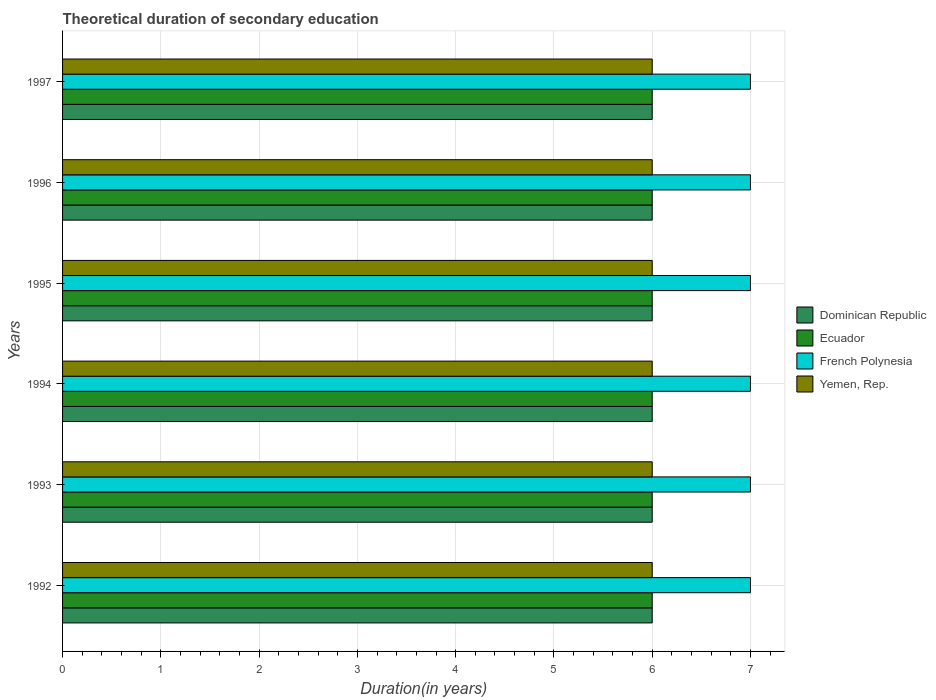How many bars are there on the 2nd tick from the bottom?
Ensure brevity in your answer.  4. In how many cases, is the number of bars for a given year not equal to the number of legend labels?
Your answer should be very brief. 0. Across all years, what is the maximum total theoretical duration of secondary education in Yemen, Rep.?
Offer a terse response. 6. Across all years, what is the minimum total theoretical duration of secondary education in French Polynesia?
Your answer should be compact. 7. In which year was the total theoretical duration of secondary education in French Polynesia maximum?
Ensure brevity in your answer.  1992. In which year was the total theoretical duration of secondary education in Ecuador minimum?
Provide a short and direct response. 1992. What is the total total theoretical duration of secondary education in Yemen, Rep. in the graph?
Provide a short and direct response. 36. What is the difference between the total theoretical duration of secondary education in Ecuador in 1995 and that in 1997?
Your response must be concise. 0. What is the average total theoretical duration of secondary education in French Polynesia per year?
Offer a very short reply. 7. In how many years, is the total theoretical duration of secondary education in Yemen, Rep. greater than 5.6 years?
Your response must be concise. 6. In how many years, is the total theoretical duration of secondary education in Yemen, Rep. greater than the average total theoretical duration of secondary education in Yemen, Rep. taken over all years?
Offer a very short reply. 0. What does the 3rd bar from the top in 1996 represents?
Provide a succinct answer. Ecuador. What does the 3rd bar from the bottom in 1996 represents?
Keep it short and to the point. French Polynesia. How many years are there in the graph?
Your response must be concise. 6. What is the difference between two consecutive major ticks on the X-axis?
Your answer should be compact. 1. Are the values on the major ticks of X-axis written in scientific E-notation?
Make the answer very short. No. Where does the legend appear in the graph?
Offer a very short reply. Center right. How many legend labels are there?
Provide a short and direct response. 4. What is the title of the graph?
Give a very brief answer. Theoretical duration of secondary education. What is the label or title of the X-axis?
Your answer should be compact. Duration(in years). What is the label or title of the Y-axis?
Make the answer very short. Years. What is the Duration(in years) in Dominican Republic in 1992?
Provide a short and direct response. 6. What is the Duration(in years) in Yemen, Rep. in 1992?
Keep it short and to the point. 6. What is the Duration(in years) in Yemen, Rep. in 1993?
Your answer should be compact. 6. What is the Duration(in years) in Ecuador in 1994?
Your answer should be very brief. 6. What is the Duration(in years) in French Polynesia in 1994?
Your answer should be compact. 7. What is the Duration(in years) of Yemen, Rep. in 1994?
Provide a succinct answer. 6. What is the Duration(in years) of Ecuador in 1995?
Provide a succinct answer. 6. What is the Duration(in years) of French Polynesia in 1995?
Your answer should be compact. 7. What is the Duration(in years) in French Polynesia in 1996?
Keep it short and to the point. 7. Across all years, what is the maximum Duration(in years) in Dominican Republic?
Keep it short and to the point. 6. Across all years, what is the maximum Duration(in years) of French Polynesia?
Make the answer very short. 7. Across all years, what is the maximum Duration(in years) in Yemen, Rep.?
Make the answer very short. 6. Across all years, what is the minimum Duration(in years) of Dominican Republic?
Your answer should be compact. 6. Across all years, what is the minimum Duration(in years) in French Polynesia?
Give a very brief answer. 7. What is the total Duration(in years) in French Polynesia in the graph?
Offer a very short reply. 42. What is the total Duration(in years) of Yemen, Rep. in the graph?
Your answer should be very brief. 36. What is the difference between the Duration(in years) in Dominican Republic in 1992 and that in 1993?
Keep it short and to the point. 0. What is the difference between the Duration(in years) in Ecuador in 1992 and that in 1993?
Your answer should be compact. 0. What is the difference between the Duration(in years) in French Polynesia in 1992 and that in 1993?
Offer a terse response. 0. What is the difference between the Duration(in years) of Yemen, Rep. in 1992 and that in 1993?
Provide a short and direct response. 0. What is the difference between the Duration(in years) of Dominican Republic in 1992 and that in 1994?
Provide a short and direct response. 0. What is the difference between the Duration(in years) of French Polynesia in 1992 and that in 1994?
Your answer should be very brief. 0. What is the difference between the Duration(in years) in Yemen, Rep. in 1992 and that in 1994?
Provide a short and direct response. 0. What is the difference between the Duration(in years) in Dominican Republic in 1992 and that in 1995?
Provide a succinct answer. 0. What is the difference between the Duration(in years) of Ecuador in 1992 and that in 1995?
Provide a succinct answer. 0. What is the difference between the Duration(in years) in French Polynesia in 1992 and that in 1995?
Your response must be concise. 0. What is the difference between the Duration(in years) of Yemen, Rep. in 1992 and that in 1995?
Your answer should be very brief. 0. What is the difference between the Duration(in years) in Dominican Republic in 1992 and that in 1996?
Your response must be concise. 0. What is the difference between the Duration(in years) in Ecuador in 1992 and that in 1996?
Provide a short and direct response. 0. What is the difference between the Duration(in years) in Yemen, Rep. in 1992 and that in 1996?
Your answer should be compact. 0. What is the difference between the Duration(in years) in Dominican Republic in 1992 and that in 1997?
Your response must be concise. 0. What is the difference between the Duration(in years) in Dominican Republic in 1993 and that in 1994?
Ensure brevity in your answer.  0. What is the difference between the Duration(in years) of Ecuador in 1993 and that in 1995?
Provide a short and direct response. 0. What is the difference between the Duration(in years) in French Polynesia in 1993 and that in 1995?
Offer a terse response. 0. What is the difference between the Duration(in years) in Yemen, Rep. in 1993 and that in 1995?
Make the answer very short. 0. What is the difference between the Duration(in years) of Dominican Republic in 1993 and that in 1996?
Your response must be concise. 0. What is the difference between the Duration(in years) of French Polynesia in 1993 and that in 1996?
Offer a terse response. 0. What is the difference between the Duration(in years) in Dominican Republic in 1993 and that in 1997?
Provide a short and direct response. 0. What is the difference between the Duration(in years) in Ecuador in 1993 and that in 1997?
Keep it short and to the point. 0. What is the difference between the Duration(in years) of Dominican Republic in 1994 and that in 1995?
Provide a short and direct response. 0. What is the difference between the Duration(in years) of French Polynesia in 1994 and that in 1995?
Your response must be concise. 0. What is the difference between the Duration(in years) in Yemen, Rep. in 1994 and that in 1995?
Your answer should be compact. 0. What is the difference between the Duration(in years) of Ecuador in 1994 and that in 1996?
Give a very brief answer. 0. What is the difference between the Duration(in years) of Yemen, Rep. in 1994 and that in 1996?
Offer a terse response. 0. What is the difference between the Duration(in years) of Dominican Republic in 1994 and that in 1997?
Provide a succinct answer. 0. What is the difference between the Duration(in years) in Yemen, Rep. in 1994 and that in 1997?
Offer a terse response. 0. What is the difference between the Duration(in years) in French Polynesia in 1995 and that in 1996?
Your answer should be compact. 0. What is the difference between the Duration(in years) in Dominican Republic in 1995 and that in 1997?
Your response must be concise. 0. What is the difference between the Duration(in years) of Yemen, Rep. in 1995 and that in 1997?
Provide a succinct answer. 0. What is the difference between the Duration(in years) in Ecuador in 1996 and that in 1997?
Your response must be concise. 0. What is the difference between the Duration(in years) of Yemen, Rep. in 1996 and that in 1997?
Ensure brevity in your answer.  0. What is the difference between the Duration(in years) of Dominican Republic in 1992 and the Duration(in years) of Ecuador in 1993?
Keep it short and to the point. 0. What is the difference between the Duration(in years) in Dominican Republic in 1992 and the Duration(in years) in Yemen, Rep. in 1993?
Your response must be concise. 0. What is the difference between the Duration(in years) of Ecuador in 1992 and the Duration(in years) of Yemen, Rep. in 1993?
Keep it short and to the point. 0. What is the difference between the Duration(in years) in French Polynesia in 1992 and the Duration(in years) in Yemen, Rep. in 1993?
Your answer should be compact. 1. What is the difference between the Duration(in years) of Dominican Republic in 1992 and the Duration(in years) of Yemen, Rep. in 1994?
Make the answer very short. 0. What is the difference between the Duration(in years) of Ecuador in 1992 and the Duration(in years) of Yemen, Rep. in 1994?
Your answer should be very brief. 0. What is the difference between the Duration(in years) of French Polynesia in 1992 and the Duration(in years) of Yemen, Rep. in 1994?
Provide a succinct answer. 1. What is the difference between the Duration(in years) of Dominican Republic in 1992 and the Duration(in years) of Ecuador in 1995?
Keep it short and to the point. 0. What is the difference between the Duration(in years) of Ecuador in 1992 and the Duration(in years) of Yemen, Rep. in 1995?
Offer a terse response. 0. What is the difference between the Duration(in years) in French Polynesia in 1992 and the Duration(in years) in Yemen, Rep. in 1995?
Give a very brief answer. 1. What is the difference between the Duration(in years) in Dominican Republic in 1992 and the Duration(in years) in French Polynesia in 1996?
Ensure brevity in your answer.  -1. What is the difference between the Duration(in years) of Dominican Republic in 1992 and the Duration(in years) of Yemen, Rep. in 1996?
Give a very brief answer. 0. What is the difference between the Duration(in years) in Ecuador in 1992 and the Duration(in years) in French Polynesia in 1996?
Offer a terse response. -1. What is the difference between the Duration(in years) of French Polynesia in 1992 and the Duration(in years) of Yemen, Rep. in 1996?
Ensure brevity in your answer.  1. What is the difference between the Duration(in years) of Dominican Republic in 1992 and the Duration(in years) of Yemen, Rep. in 1997?
Offer a very short reply. 0. What is the difference between the Duration(in years) of Ecuador in 1992 and the Duration(in years) of French Polynesia in 1997?
Give a very brief answer. -1. What is the difference between the Duration(in years) of Ecuador in 1993 and the Duration(in years) of French Polynesia in 1994?
Ensure brevity in your answer.  -1. What is the difference between the Duration(in years) in Ecuador in 1993 and the Duration(in years) in Yemen, Rep. in 1994?
Your answer should be very brief. 0. What is the difference between the Duration(in years) of French Polynesia in 1993 and the Duration(in years) of Yemen, Rep. in 1994?
Your answer should be very brief. 1. What is the difference between the Duration(in years) in Ecuador in 1993 and the Duration(in years) in French Polynesia in 1995?
Provide a short and direct response. -1. What is the difference between the Duration(in years) of French Polynesia in 1993 and the Duration(in years) of Yemen, Rep. in 1995?
Make the answer very short. 1. What is the difference between the Duration(in years) in Dominican Republic in 1993 and the Duration(in years) in French Polynesia in 1996?
Your answer should be very brief. -1. What is the difference between the Duration(in years) in Ecuador in 1993 and the Duration(in years) in French Polynesia in 1996?
Your answer should be compact. -1. What is the difference between the Duration(in years) in Ecuador in 1993 and the Duration(in years) in Yemen, Rep. in 1996?
Give a very brief answer. 0. What is the difference between the Duration(in years) in Dominican Republic in 1993 and the Duration(in years) in Ecuador in 1997?
Ensure brevity in your answer.  0. What is the difference between the Duration(in years) in Ecuador in 1993 and the Duration(in years) in Yemen, Rep. in 1997?
Offer a very short reply. 0. What is the difference between the Duration(in years) in French Polynesia in 1993 and the Duration(in years) in Yemen, Rep. in 1997?
Your answer should be very brief. 1. What is the difference between the Duration(in years) in Ecuador in 1994 and the Duration(in years) in French Polynesia in 1995?
Offer a terse response. -1. What is the difference between the Duration(in years) in French Polynesia in 1994 and the Duration(in years) in Yemen, Rep. in 1995?
Offer a terse response. 1. What is the difference between the Duration(in years) of Dominican Republic in 1994 and the Duration(in years) of Ecuador in 1996?
Your answer should be compact. 0. What is the difference between the Duration(in years) in Dominican Republic in 1994 and the Duration(in years) in French Polynesia in 1996?
Offer a terse response. -1. What is the difference between the Duration(in years) in Dominican Republic in 1994 and the Duration(in years) in Yemen, Rep. in 1996?
Your answer should be compact. 0. What is the difference between the Duration(in years) in Ecuador in 1994 and the Duration(in years) in French Polynesia in 1996?
Give a very brief answer. -1. What is the difference between the Duration(in years) in Ecuador in 1994 and the Duration(in years) in Yemen, Rep. in 1996?
Provide a succinct answer. 0. What is the difference between the Duration(in years) in French Polynesia in 1994 and the Duration(in years) in Yemen, Rep. in 1996?
Keep it short and to the point. 1. What is the difference between the Duration(in years) of Dominican Republic in 1994 and the Duration(in years) of Yemen, Rep. in 1997?
Your response must be concise. 0. What is the difference between the Duration(in years) of French Polynesia in 1994 and the Duration(in years) of Yemen, Rep. in 1997?
Offer a terse response. 1. What is the difference between the Duration(in years) in Dominican Republic in 1995 and the Duration(in years) in Ecuador in 1996?
Offer a very short reply. 0. What is the difference between the Duration(in years) of Dominican Republic in 1995 and the Duration(in years) of French Polynesia in 1996?
Your response must be concise. -1. What is the difference between the Duration(in years) of Ecuador in 1995 and the Duration(in years) of French Polynesia in 1996?
Give a very brief answer. -1. What is the difference between the Duration(in years) in Ecuador in 1995 and the Duration(in years) in Yemen, Rep. in 1996?
Your answer should be very brief. 0. What is the difference between the Duration(in years) in Dominican Republic in 1995 and the Duration(in years) in Ecuador in 1997?
Your answer should be compact. 0. What is the difference between the Duration(in years) of Dominican Republic in 1995 and the Duration(in years) of Yemen, Rep. in 1997?
Give a very brief answer. 0. What is the difference between the Duration(in years) of Ecuador in 1995 and the Duration(in years) of French Polynesia in 1997?
Ensure brevity in your answer.  -1. What is the difference between the Duration(in years) of Ecuador in 1995 and the Duration(in years) of Yemen, Rep. in 1997?
Keep it short and to the point. 0. What is the difference between the Duration(in years) in Dominican Republic in 1996 and the Duration(in years) in French Polynesia in 1997?
Your answer should be very brief. -1. What is the difference between the Duration(in years) of Ecuador in 1996 and the Duration(in years) of French Polynesia in 1997?
Ensure brevity in your answer.  -1. What is the difference between the Duration(in years) of Ecuador in 1996 and the Duration(in years) of Yemen, Rep. in 1997?
Ensure brevity in your answer.  0. What is the difference between the Duration(in years) of French Polynesia in 1996 and the Duration(in years) of Yemen, Rep. in 1997?
Your answer should be very brief. 1. What is the average Duration(in years) in Dominican Republic per year?
Provide a succinct answer. 6. What is the average Duration(in years) in French Polynesia per year?
Your answer should be very brief. 7. In the year 1992, what is the difference between the Duration(in years) of Dominican Republic and Duration(in years) of Ecuador?
Keep it short and to the point. 0. In the year 1992, what is the difference between the Duration(in years) of Ecuador and Duration(in years) of Yemen, Rep.?
Your answer should be compact. 0. In the year 1993, what is the difference between the Duration(in years) of Dominican Republic and Duration(in years) of Ecuador?
Offer a very short reply. 0. In the year 1993, what is the difference between the Duration(in years) in Dominican Republic and Duration(in years) in Yemen, Rep.?
Keep it short and to the point. 0. In the year 1993, what is the difference between the Duration(in years) in Ecuador and Duration(in years) in Yemen, Rep.?
Provide a succinct answer. 0. In the year 1993, what is the difference between the Duration(in years) in French Polynesia and Duration(in years) in Yemen, Rep.?
Your response must be concise. 1. In the year 1994, what is the difference between the Duration(in years) of Dominican Republic and Duration(in years) of French Polynesia?
Provide a succinct answer. -1. In the year 1994, what is the difference between the Duration(in years) of Dominican Republic and Duration(in years) of Yemen, Rep.?
Your answer should be compact. 0. In the year 1994, what is the difference between the Duration(in years) of Ecuador and Duration(in years) of French Polynesia?
Offer a terse response. -1. In the year 1994, what is the difference between the Duration(in years) of Ecuador and Duration(in years) of Yemen, Rep.?
Keep it short and to the point. 0. In the year 1994, what is the difference between the Duration(in years) of French Polynesia and Duration(in years) of Yemen, Rep.?
Give a very brief answer. 1. In the year 1995, what is the difference between the Duration(in years) of Dominican Republic and Duration(in years) of Ecuador?
Your response must be concise. 0. In the year 1995, what is the difference between the Duration(in years) of Dominican Republic and Duration(in years) of French Polynesia?
Provide a short and direct response. -1. In the year 1995, what is the difference between the Duration(in years) in Ecuador and Duration(in years) in Yemen, Rep.?
Give a very brief answer. 0. In the year 1996, what is the difference between the Duration(in years) in Dominican Republic and Duration(in years) in Ecuador?
Your response must be concise. 0. In the year 1996, what is the difference between the Duration(in years) of Dominican Republic and Duration(in years) of French Polynesia?
Provide a succinct answer. -1. In the year 1996, what is the difference between the Duration(in years) in Dominican Republic and Duration(in years) in Yemen, Rep.?
Your answer should be very brief. 0. In the year 1996, what is the difference between the Duration(in years) in Ecuador and Duration(in years) in Yemen, Rep.?
Your answer should be very brief. 0. In the year 1997, what is the difference between the Duration(in years) of Dominican Republic and Duration(in years) of French Polynesia?
Provide a short and direct response. -1. In the year 1997, what is the difference between the Duration(in years) in French Polynesia and Duration(in years) in Yemen, Rep.?
Provide a short and direct response. 1. What is the ratio of the Duration(in years) in Dominican Republic in 1992 to that in 1993?
Your answer should be very brief. 1. What is the ratio of the Duration(in years) in Ecuador in 1992 to that in 1993?
Your answer should be compact. 1. What is the ratio of the Duration(in years) in Ecuador in 1992 to that in 1994?
Ensure brevity in your answer.  1. What is the ratio of the Duration(in years) of Ecuador in 1992 to that in 1995?
Your answer should be very brief. 1. What is the ratio of the Duration(in years) in Ecuador in 1992 to that in 1996?
Offer a terse response. 1. What is the ratio of the Duration(in years) in Dominican Republic in 1992 to that in 1997?
Your response must be concise. 1. What is the ratio of the Duration(in years) of Ecuador in 1992 to that in 1997?
Your answer should be very brief. 1. What is the ratio of the Duration(in years) in French Polynesia in 1992 to that in 1997?
Your response must be concise. 1. What is the ratio of the Duration(in years) of Yemen, Rep. in 1992 to that in 1997?
Make the answer very short. 1. What is the ratio of the Duration(in years) of Ecuador in 1993 to that in 1994?
Keep it short and to the point. 1. What is the ratio of the Duration(in years) of French Polynesia in 1993 to that in 1994?
Give a very brief answer. 1. What is the ratio of the Duration(in years) in Yemen, Rep. in 1993 to that in 1994?
Provide a short and direct response. 1. What is the ratio of the Duration(in years) of Ecuador in 1993 to that in 1995?
Your answer should be very brief. 1. What is the ratio of the Duration(in years) in French Polynesia in 1993 to that in 1995?
Offer a terse response. 1. What is the ratio of the Duration(in years) of Yemen, Rep. in 1993 to that in 1995?
Your answer should be compact. 1. What is the ratio of the Duration(in years) of Dominican Republic in 1993 to that in 1996?
Offer a terse response. 1. What is the ratio of the Duration(in years) in Ecuador in 1993 to that in 1996?
Make the answer very short. 1. What is the ratio of the Duration(in years) in Yemen, Rep. in 1993 to that in 1996?
Provide a short and direct response. 1. What is the ratio of the Duration(in years) of Dominican Republic in 1993 to that in 1997?
Provide a succinct answer. 1. What is the ratio of the Duration(in years) of Ecuador in 1993 to that in 1997?
Provide a short and direct response. 1. What is the ratio of the Duration(in years) in Dominican Republic in 1994 to that in 1995?
Make the answer very short. 1. What is the ratio of the Duration(in years) in Ecuador in 1994 to that in 1995?
Make the answer very short. 1. What is the ratio of the Duration(in years) of Ecuador in 1994 to that in 1996?
Offer a very short reply. 1. What is the ratio of the Duration(in years) in French Polynesia in 1994 to that in 1996?
Provide a succinct answer. 1. What is the ratio of the Duration(in years) in Yemen, Rep. in 1994 to that in 1996?
Make the answer very short. 1. What is the ratio of the Duration(in years) of Dominican Republic in 1994 to that in 1997?
Keep it short and to the point. 1. What is the ratio of the Duration(in years) in Ecuador in 1994 to that in 1997?
Your response must be concise. 1. What is the ratio of the Duration(in years) of French Polynesia in 1994 to that in 1997?
Give a very brief answer. 1. What is the ratio of the Duration(in years) in Yemen, Rep. in 1994 to that in 1997?
Provide a succinct answer. 1. What is the ratio of the Duration(in years) of French Polynesia in 1995 to that in 1996?
Your answer should be very brief. 1. What is the ratio of the Duration(in years) of Yemen, Rep. in 1995 to that in 1996?
Make the answer very short. 1. What is the ratio of the Duration(in years) in Dominican Republic in 1995 to that in 1997?
Your answer should be very brief. 1. What is the ratio of the Duration(in years) in Ecuador in 1995 to that in 1997?
Your answer should be compact. 1. What is the ratio of the Duration(in years) of Yemen, Rep. in 1995 to that in 1997?
Your response must be concise. 1. What is the ratio of the Duration(in years) in Dominican Republic in 1996 to that in 1997?
Your answer should be compact. 1. What is the ratio of the Duration(in years) of Ecuador in 1996 to that in 1997?
Keep it short and to the point. 1. What is the ratio of the Duration(in years) in French Polynesia in 1996 to that in 1997?
Your answer should be very brief. 1. What is the difference between the highest and the second highest Duration(in years) of Yemen, Rep.?
Provide a succinct answer. 0. What is the difference between the highest and the lowest Duration(in years) in Dominican Republic?
Offer a very short reply. 0. What is the difference between the highest and the lowest Duration(in years) of Ecuador?
Keep it short and to the point. 0. What is the difference between the highest and the lowest Duration(in years) of Yemen, Rep.?
Ensure brevity in your answer.  0. 